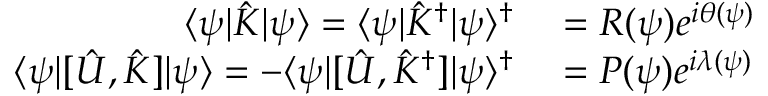Convert formula to latex. <formula><loc_0><loc_0><loc_500><loc_500>\begin{array} { r l } { \langle \psi | \hat { K } | \psi \rangle = \langle \psi | \hat { K } ^ { \dag } | \psi \rangle ^ { \dag } } & = R ( \psi ) e ^ { i \theta ( \psi ) } } \\ { \langle \psi | [ \hat { U } , \hat { K } ] | \psi \rangle = - \langle \psi | [ \hat { U } , \hat { K } ^ { \dag } ] | \psi \rangle ^ { \dag } } & = P ( \psi ) e ^ { i \lambda ( \psi ) } } \end{array}</formula> 